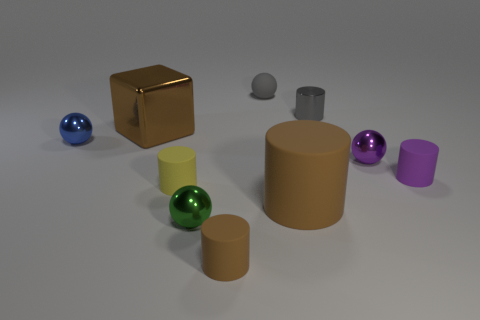Besides the spheres and cylinders, are there any other geometric shapes present? Yes, in addition to the spheres and cylinders, there is also a cube with a reflective golden surface. What could the various shapes in the image be used to represent or demonstrate? The array of geometric shapes could be used for various purposes such as a demonstration in a physics engine, showcasing how light and shadows interact with different colors and surfaces, or as a visual aid in an educational setting to teach about geometry and spatial relationships. 